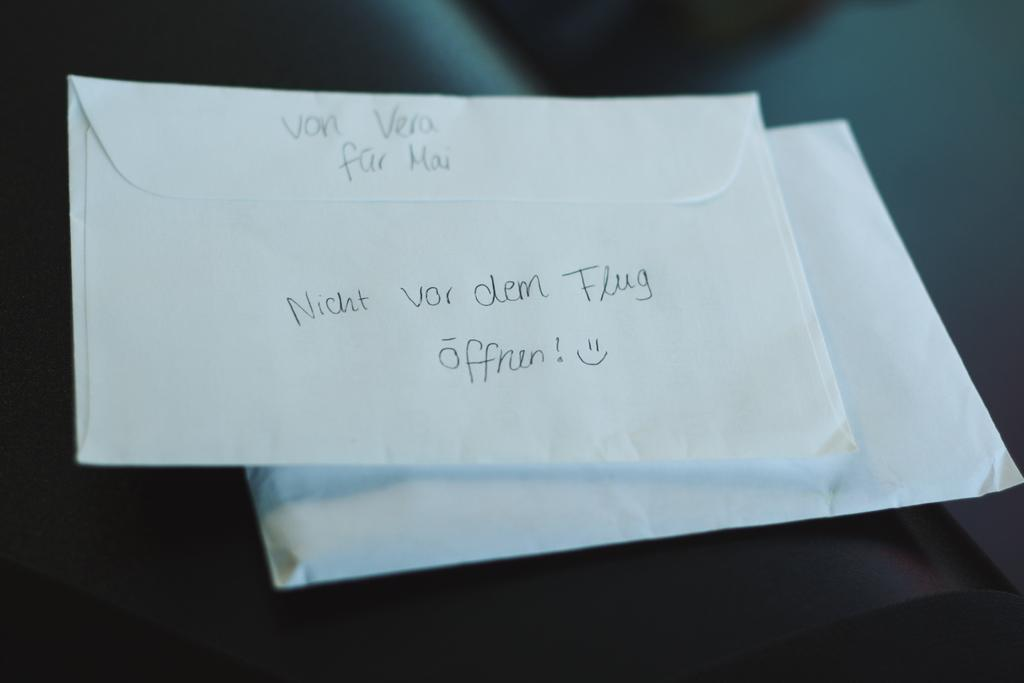<image>
Provide a brief description of the given image. On the top of the envelop von vera far mai is written. 